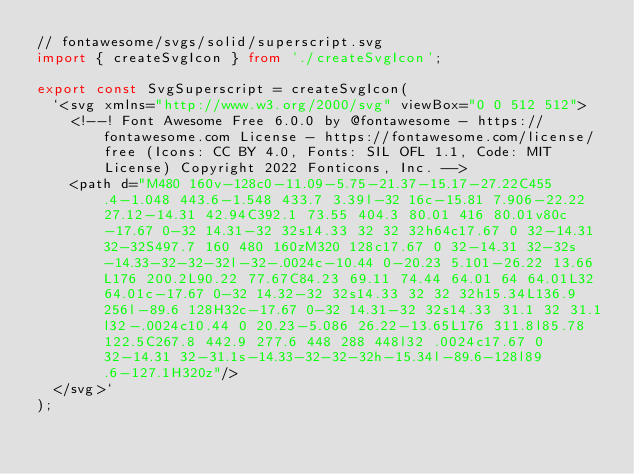<code> <loc_0><loc_0><loc_500><loc_500><_TypeScript_>// fontawesome/svgs/solid/superscript.svg
import { createSvgIcon } from './createSvgIcon';

export const SvgSuperscript = createSvgIcon(
  `<svg xmlns="http://www.w3.org/2000/svg" viewBox="0 0 512 512">
    <!--! Font Awesome Free 6.0.0 by @fontawesome - https://fontawesome.com License - https://fontawesome.com/license/free (Icons: CC BY 4.0, Fonts: SIL OFL 1.1, Code: MIT License) Copyright 2022 Fonticons, Inc. -->
    <path d="M480 160v-128c0-11.09-5.75-21.37-15.17-27.22C455.4-1.048 443.6-1.548 433.7 3.39l-32 16c-15.81 7.906-22.22 27.12-14.31 42.94C392.1 73.55 404.3 80.01 416 80.01v80c-17.67 0-32 14.31-32 32s14.33 32 32 32h64c17.67 0 32-14.31 32-32S497.7 160 480 160zM320 128c17.67 0 32-14.31 32-32s-14.33-32-32-32l-32-.0024c-10.44 0-20.23 5.101-26.22 13.66L176 200.2L90.22 77.67C84.23 69.11 74.44 64.01 64 64.01L32 64.01c-17.67 0-32 14.32-32 32s14.33 32 32 32h15.34L136.9 256l-89.6 128H32c-17.67 0-32 14.31-32 32s14.33 31.1 32 31.1l32-.0024c10.44 0 20.23-5.086 26.22-13.65L176 311.8l85.78 122.5C267.8 442.9 277.6 448 288 448l32 .0024c17.67 0 32-14.31 32-31.1s-14.33-32-32-32h-15.34l-89.6-128l89.6-127.1H320z"/>
  </svg>`
);

</code> 